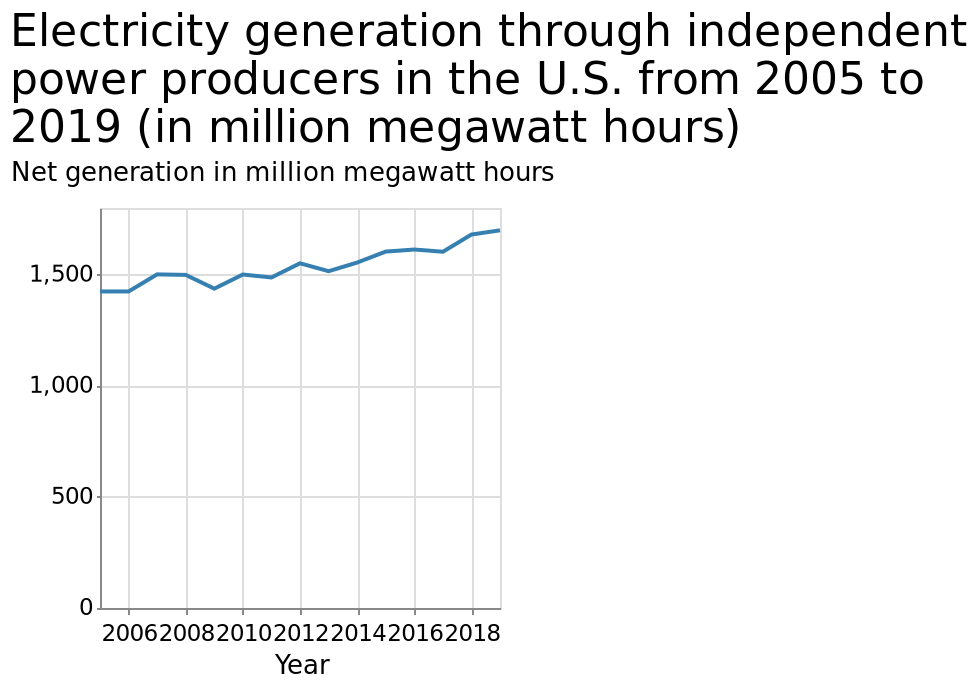<image>
How would you describe the trend of the generation from 2008 to 2018? The trend of the generation from 2008 to 2018 shows a drop in 2010 followed by a steady increase towards its highest point in 2018. What does the y-axis represent on the line chart? The y-axis represents net generation in million megawatt hours. please enumerates aspects of the construction of the chart Electricity generation through independent power producers in the U.S. from 2005 to 2019 (in million megawatt hours) is a line chart. The x-axis measures Year along a linear scale from 2006 to 2018. There is a linear scale from 0 to 1,500 along the y-axis, marked Net generation in million megawatt hours. 